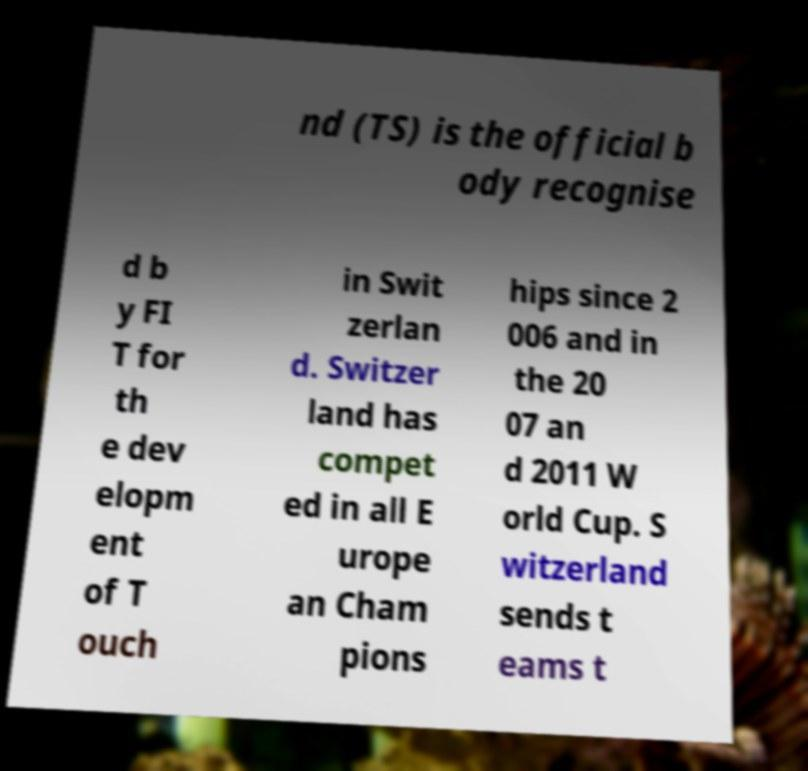For documentation purposes, I need the text within this image transcribed. Could you provide that? nd (TS) is the official b ody recognise d b y FI T for th e dev elopm ent of T ouch in Swit zerlan d. Switzer land has compet ed in all E urope an Cham pions hips since 2 006 and in the 20 07 an d 2011 W orld Cup. S witzerland sends t eams t 